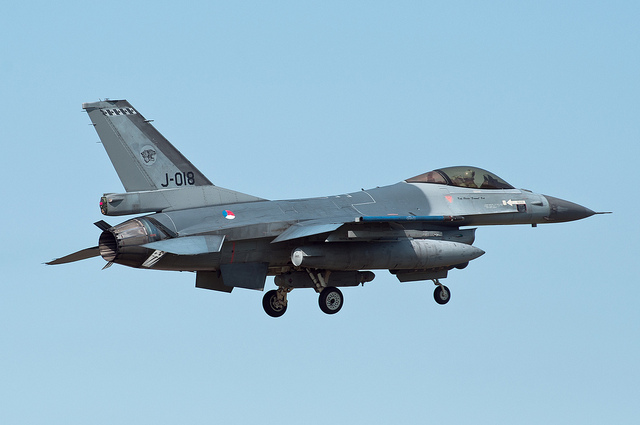Read all the text in this image. J-018 